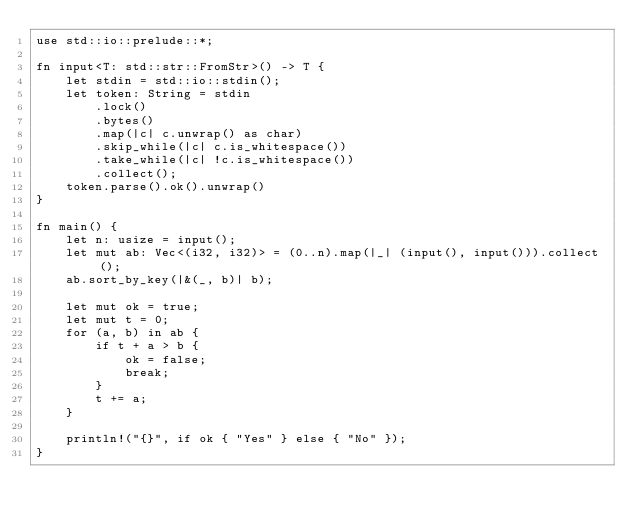Convert code to text. <code><loc_0><loc_0><loc_500><loc_500><_Rust_>use std::io::prelude::*;

fn input<T: std::str::FromStr>() -> T {
    let stdin = std::io::stdin();
    let token: String = stdin
        .lock()
        .bytes()
        .map(|c| c.unwrap() as char)
        .skip_while(|c| c.is_whitespace())
        .take_while(|c| !c.is_whitespace())
        .collect();
    token.parse().ok().unwrap()
}

fn main() {
    let n: usize = input();
    let mut ab: Vec<(i32, i32)> = (0..n).map(|_| (input(), input())).collect();
    ab.sort_by_key(|&(_, b)| b);

    let mut ok = true;
    let mut t = 0;
    for (a, b) in ab {
        if t + a > b {
            ok = false;
            break;
        }
        t += a;
    }

    println!("{}", if ok { "Yes" } else { "No" });
}
</code> 